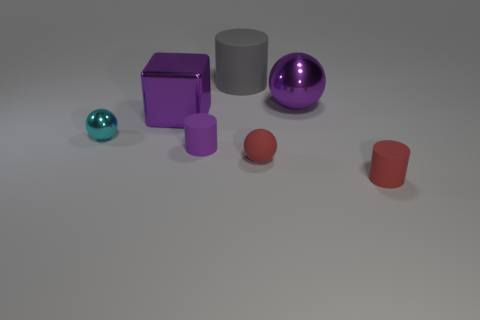Add 2 cyan rubber things. How many objects exist? 9 Subtract all spheres. How many objects are left? 4 Add 4 big red metallic objects. How many big red metallic objects exist? 4 Subtract 0 brown spheres. How many objects are left? 7 Subtract all purple balls. Subtract all big rubber things. How many objects are left? 5 Add 2 cyan spheres. How many cyan spheres are left? 3 